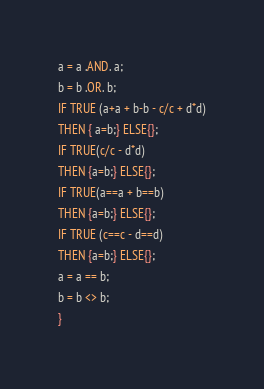<code> <loc_0><loc_0><loc_500><loc_500><_SQL_>a = a .AND. a;
b = b .OR. b;
IF TRUE (a+a + b-b - c/c + d*d)
THEN { a=b;} ELSE{};
IF TRUE(c/c - d*d)
THEN {a=b;} ELSE{};
IF TRUE(a==a + b==b)
THEN {a=b;} ELSE{};
IF TRUE (c==c - d==d)
THEN {a=b;} ELSE{};
a = a == b;
b = b <> b; 
}</code> 